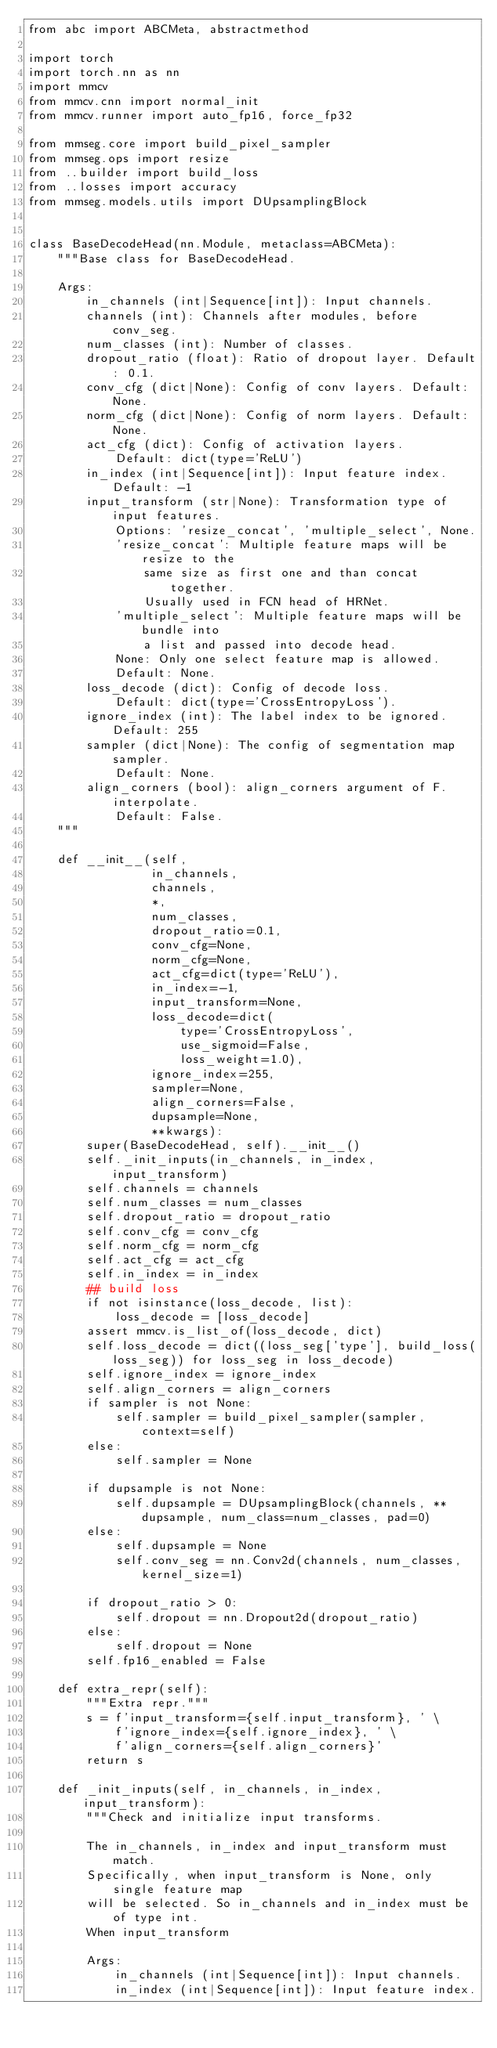<code> <loc_0><loc_0><loc_500><loc_500><_Python_>from abc import ABCMeta, abstractmethod

import torch
import torch.nn as nn
import mmcv
from mmcv.cnn import normal_init
from mmcv.runner import auto_fp16, force_fp32

from mmseg.core import build_pixel_sampler
from mmseg.ops import resize
from ..builder import build_loss
from ..losses import accuracy
from mmseg.models.utils import DUpsamplingBlock


class BaseDecodeHead(nn.Module, metaclass=ABCMeta):
    """Base class for BaseDecodeHead.

    Args:
        in_channels (int|Sequence[int]): Input channels.
        channels (int): Channels after modules, before conv_seg.
        num_classes (int): Number of classes.
        dropout_ratio (float): Ratio of dropout layer. Default: 0.1.
        conv_cfg (dict|None): Config of conv layers. Default: None.
        norm_cfg (dict|None): Config of norm layers. Default: None.
        act_cfg (dict): Config of activation layers.
            Default: dict(type='ReLU')
        in_index (int|Sequence[int]): Input feature index. Default: -1
        input_transform (str|None): Transformation type of input features.
            Options: 'resize_concat', 'multiple_select', None.
            'resize_concat': Multiple feature maps will be resize to the
                same size as first one and than concat together.
                Usually used in FCN head of HRNet.
            'multiple_select': Multiple feature maps will be bundle into
                a list and passed into decode head.
            None: Only one select feature map is allowed.
            Default: None.
        loss_decode (dict): Config of decode loss.
            Default: dict(type='CrossEntropyLoss').
        ignore_index (int): The label index to be ignored. Default: 255
        sampler (dict|None): The config of segmentation map sampler.
            Default: None.
        align_corners (bool): align_corners argument of F.interpolate.
            Default: False.
    """

    def __init__(self,
                 in_channels,
                 channels,
                 *,
                 num_classes,
                 dropout_ratio=0.1,
                 conv_cfg=None,
                 norm_cfg=None,
                 act_cfg=dict(type='ReLU'),
                 in_index=-1,
                 input_transform=None,
                 loss_decode=dict(
                     type='CrossEntropyLoss',
                     use_sigmoid=False,
                     loss_weight=1.0),
                 ignore_index=255,
                 sampler=None,
                 align_corners=False,
                 dupsample=None,
                 **kwargs):
        super(BaseDecodeHead, self).__init__()
        self._init_inputs(in_channels, in_index, input_transform)
        self.channels = channels
        self.num_classes = num_classes
        self.dropout_ratio = dropout_ratio
        self.conv_cfg = conv_cfg
        self.norm_cfg = norm_cfg
        self.act_cfg = act_cfg
        self.in_index = in_index
        ## build loss
        if not isinstance(loss_decode, list):
            loss_decode = [loss_decode]
        assert mmcv.is_list_of(loss_decode, dict)
        self.loss_decode = dict((loss_seg['type'], build_loss(loss_seg)) for loss_seg in loss_decode)
        self.ignore_index = ignore_index
        self.align_corners = align_corners
        if sampler is not None:
            self.sampler = build_pixel_sampler(sampler, context=self)
        else:
            self.sampler = None

        if dupsample is not None:
            self.dupsample = DUpsamplingBlock(channels, **dupsample, num_class=num_classes, pad=0)
        else:
            self.dupsample = None
            self.conv_seg = nn.Conv2d(channels, num_classes, kernel_size=1)

        if dropout_ratio > 0:
            self.dropout = nn.Dropout2d(dropout_ratio)
        else:
            self.dropout = None
        self.fp16_enabled = False

    def extra_repr(self):
        """Extra repr."""
        s = f'input_transform={self.input_transform}, ' \
            f'ignore_index={self.ignore_index}, ' \
            f'align_corners={self.align_corners}'
        return s

    def _init_inputs(self, in_channels, in_index, input_transform):
        """Check and initialize input transforms.

        The in_channels, in_index and input_transform must match.
        Specifically, when input_transform is None, only single feature map
        will be selected. So in_channels and in_index must be of type int.
        When input_transform

        Args:
            in_channels (int|Sequence[int]): Input channels.
            in_index (int|Sequence[int]): Input feature index.</code> 